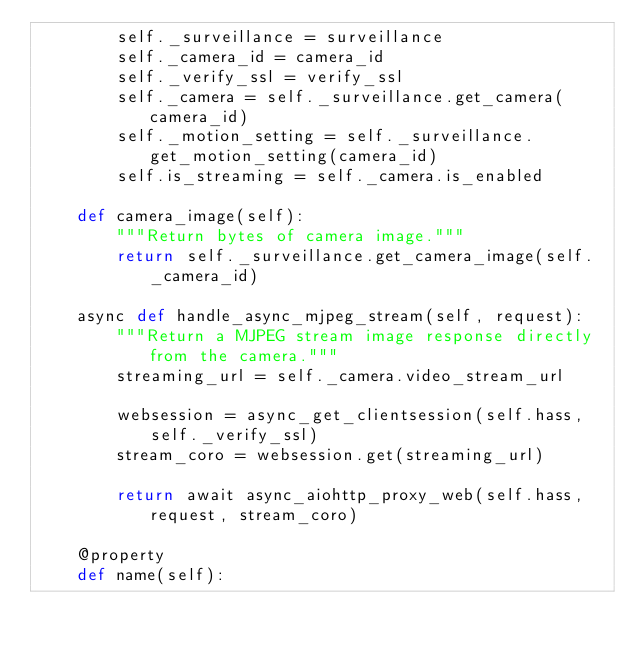<code> <loc_0><loc_0><loc_500><loc_500><_Python_>        self._surveillance = surveillance
        self._camera_id = camera_id
        self._verify_ssl = verify_ssl
        self._camera = self._surveillance.get_camera(camera_id)
        self._motion_setting = self._surveillance.get_motion_setting(camera_id)
        self.is_streaming = self._camera.is_enabled

    def camera_image(self):
        """Return bytes of camera image."""
        return self._surveillance.get_camera_image(self._camera_id)

    async def handle_async_mjpeg_stream(self, request):
        """Return a MJPEG stream image response directly from the camera."""
        streaming_url = self._camera.video_stream_url

        websession = async_get_clientsession(self.hass, self._verify_ssl)
        stream_coro = websession.get(streaming_url)

        return await async_aiohttp_proxy_web(self.hass, request, stream_coro)

    @property
    def name(self):</code> 